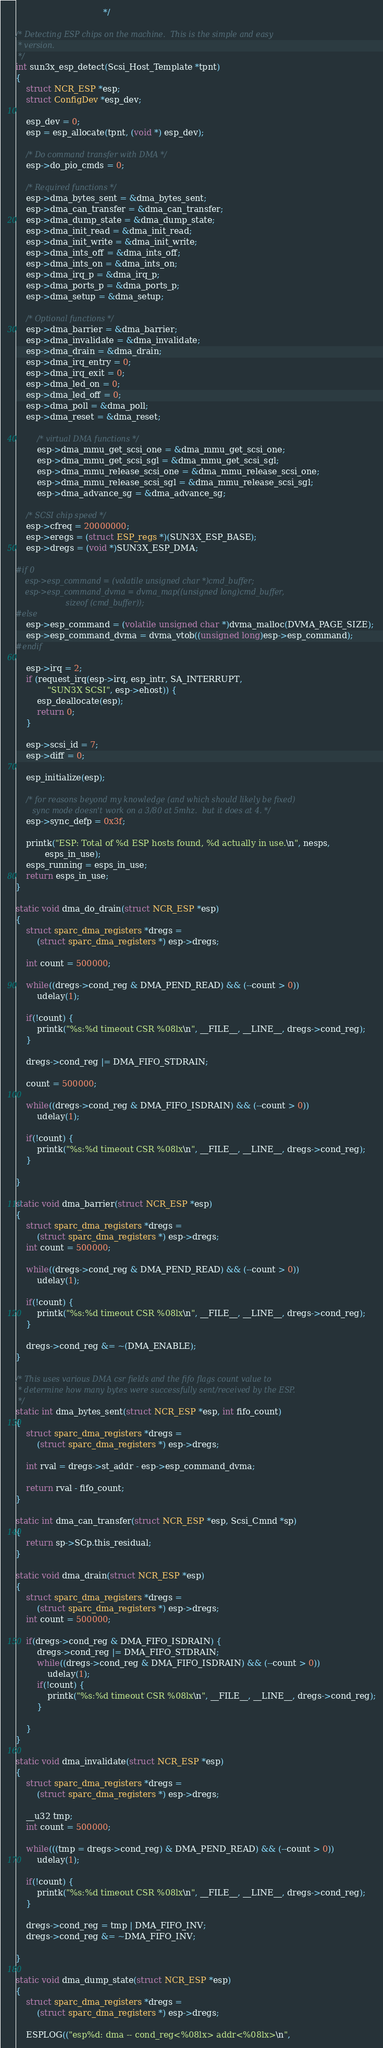Convert code to text. <code><loc_0><loc_0><loc_500><loc_500><_C_>                                 */

/* Detecting ESP chips on the machine.  This is the simple and easy
 * version.
 */
int sun3x_esp_detect(Scsi_Host_Template *tpnt)
{
	struct NCR_ESP *esp;
	struct ConfigDev *esp_dev;

	esp_dev = 0;
	esp = esp_allocate(tpnt, (void *) esp_dev);

	/* Do command transfer with DMA */
	esp->do_pio_cmds = 0;

	/* Required functions */
	esp->dma_bytes_sent = &dma_bytes_sent;
	esp->dma_can_transfer = &dma_can_transfer;
	esp->dma_dump_state = &dma_dump_state;
	esp->dma_init_read = &dma_init_read;
	esp->dma_init_write = &dma_init_write;
	esp->dma_ints_off = &dma_ints_off;
	esp->dma_ints_on = &dma_ints_on;
	esp->dma_irq_p = &dma_irq_p;
	esp->dma_ports_p = &dma_ports_p;
	esp->dma_setup = &dma_setup;

	/* Optional functions */
	esp->dma_barrier = &dma_barrier;
	esp->dma_invalidate = &dma_invalidate;
	esp->dma_drain = &dma_drain;
	esp->dma_irq_entry = 0;
	esp->dma_irq_exit = 0;
	esp->dma_led_on = 0;
	esp->dma_led_off = 0;
	esp->dma_poll = &dma_poll;
	esp->dma_reset = &dma_reset;

        /* virtual DMA functions */
        esp->dma_mmu_get_scsi_one = &dma_mmu_get_scsi_one;
        esp->dma_mmu_get_scsi_sgl = &dma_mmu_get_scsi_sgl;
        esp->dma_mmu_release_scsi_one = &dma_mmu_release_scsi_one;
        esp->dma_mmu_release_scsi_sgl = &dma_mmu_release_scsi_sgl;
        esp->dma_advance_sg = &dma_advance_sg;
	    
	/* SCSI chip speed */
	esp->cfreq = 20000000;
	esp->eregs = (struct ESP_regs *)(SUN3X_ESP_BASE);
	esp->dregs = (void *)SUN3X_ESP_DMA;

#if 0
  	esp->esp_command = (volatile unsigned char *)cmd_buffer;
 	esp->esp_command_dvma = dvma_map((unsigned long)cmd_buffer,
 					 sizeof (cmd_buffer));
#else
	esp->esp_command = (volatile unsigned char *)dvma_malloc(DVMA_PAGE_SIZE);
	esp->esp_command_dvma = dvma_vtob((unsigned long)esp->esp_command);
#endif

	esp->irq = 2;
	if (request_irq(esp->irq, esp_intr, SA_INTERRUPT, 
			"SUN3X SCSI", esp->ehost)) {
		esp_deallocate(esp);
		return 0;
	}

	esp->scsi_id = 7;
	esp->diff = 0;

	esp_initialize(esp);

 	/* for reasons beyond my knowledge (and which should likely be fixed)
 	   sync mode doesn't work on a 3/80 at 5mhz.  but it does at 4. */
 	esp->sync_defp = 0x3f;

	printk("ESP: Total of %d ESP hosts found, %d actually in use.\n", nesps,
	       esps_in_use);
	esps_running = esps_in_use;
	return esps_in_use;
}

static void dma_do_drain(struct NCR_ESP *esp)
{
 	struct sparc_dma_registers *dregs =
 		(struct sparc_dma_registers *) esp->dregs;
 	
 	int count = 500000;
 
 	while((dregs->cond_reg & DMA_PEND_READ) && (--count > 0)) 
 		udelay(1);
 
 	if(!count) {
 		printk("%s:%d timeout CSR %08lx\n", __FILE__, __LINE__, dregs->cond_reg);
 	}
 
 	dregs->cond_reg |= DMA_FIFO_STDRAIN;
 	
 	count = 500000;
 
 	while((dregs->cond_reg & DMA_FIFO_ISDRAIN) && (--count > 0)) 
 		udelay(1);
 
 	if(!count) {
 		printk("%s:%d timeout CSR %08lx\n", __FILE__, __LINE__, dregs->cond_reg);
 	}
 
}
 
static void dma_barrier(struct NCR_ESP *esp)
{
  	struct sparc_dma_registers *dregs =
  		(struct sparc_dma_registers *) esp->dregs;
 	int count = 500000;
  
 	while((dregs->cond_reg & DMA_PEND_READ) && (--count > 0))
  		udelay(1);
 
 	if(!count) {
 		printk("%s:%d timeout CSR %08lx\n", __FILE__, __LINE__, dregs->cond_reg);
 	}
 
  	dregs->cond_reg &= ~(DMA_ENABLE);
}

/* This uses various DMA csr fields and the fifo flags count value to
 * determine how many bytes were successfully sent/received by the ESP.
 */
static int dma_bytes_sent(struct NCR_ESP *esp, int fifo_count)
{
	struct sparc_dma_registers *dregs = 
		(struct sparc_dma_registers *) esp->dregs;

	int rval = dregs->st_addr - esp->esp_command_dvma;

	return rval - fifo_count;
}

static int dma_can_transfer(struct NCR_ESP *esp, Scsi_Cmnd *sp)
{
	return sp->SCp.this_residual;
}

static void dma_drain(struct NCR_ESP *esp)
{
	struct sparc_dma_registers *dregs =
		(struct sparc_dma_registers *) esp->dregs;
	int count = 500000;

	if(dregs->cond_reg & DMA_FIFO_ISDRAIN) {
		dregs->cond_reg |= DMA_FIFO_STDRAIN;
		while((dregs->cond_reg & DMA_FIFO_ISDRAIN) && (--count > 0))
			udelay(1);
		if(!count) {
			printk("%s:%d timeout CSR %08lx\n", __FILE__, __LINE__, dregs->cond_reg);
		}

	}
}

static void dma_invalidate(struct NCR_ESP *esp)
{
	struct sparc_dma_registers *dregs =
		(struct sparc_dma_registers *) esp->dregs;

	__u32 tmp;
	int count = 500000;

	while(((tmp = dregs->cond_reg) & DMA_PEND_READ) && (--count > 0)) 
		udelay(1);

	if(!count) {
		printk("%s:%d timeout CSR %08lx\n", __FILE__, __LINE__, dregs->cond_reg);
	}

	dregs->cond_reg = tmp | DMA_FIFO_INV;
	dregs->cond_reg &= ~DMA_FIFO_INV;

}

static void dma_dump_state(struct NCR_ESP *esp)
{
	struct sparc_dma_registers *dregs =
		(struct sparc_dma_registers *) esp->dregs;

	ESPLOG(("esp%d: dma -- cond_reg<%08lx> addr<%08lx>\n",</code> 